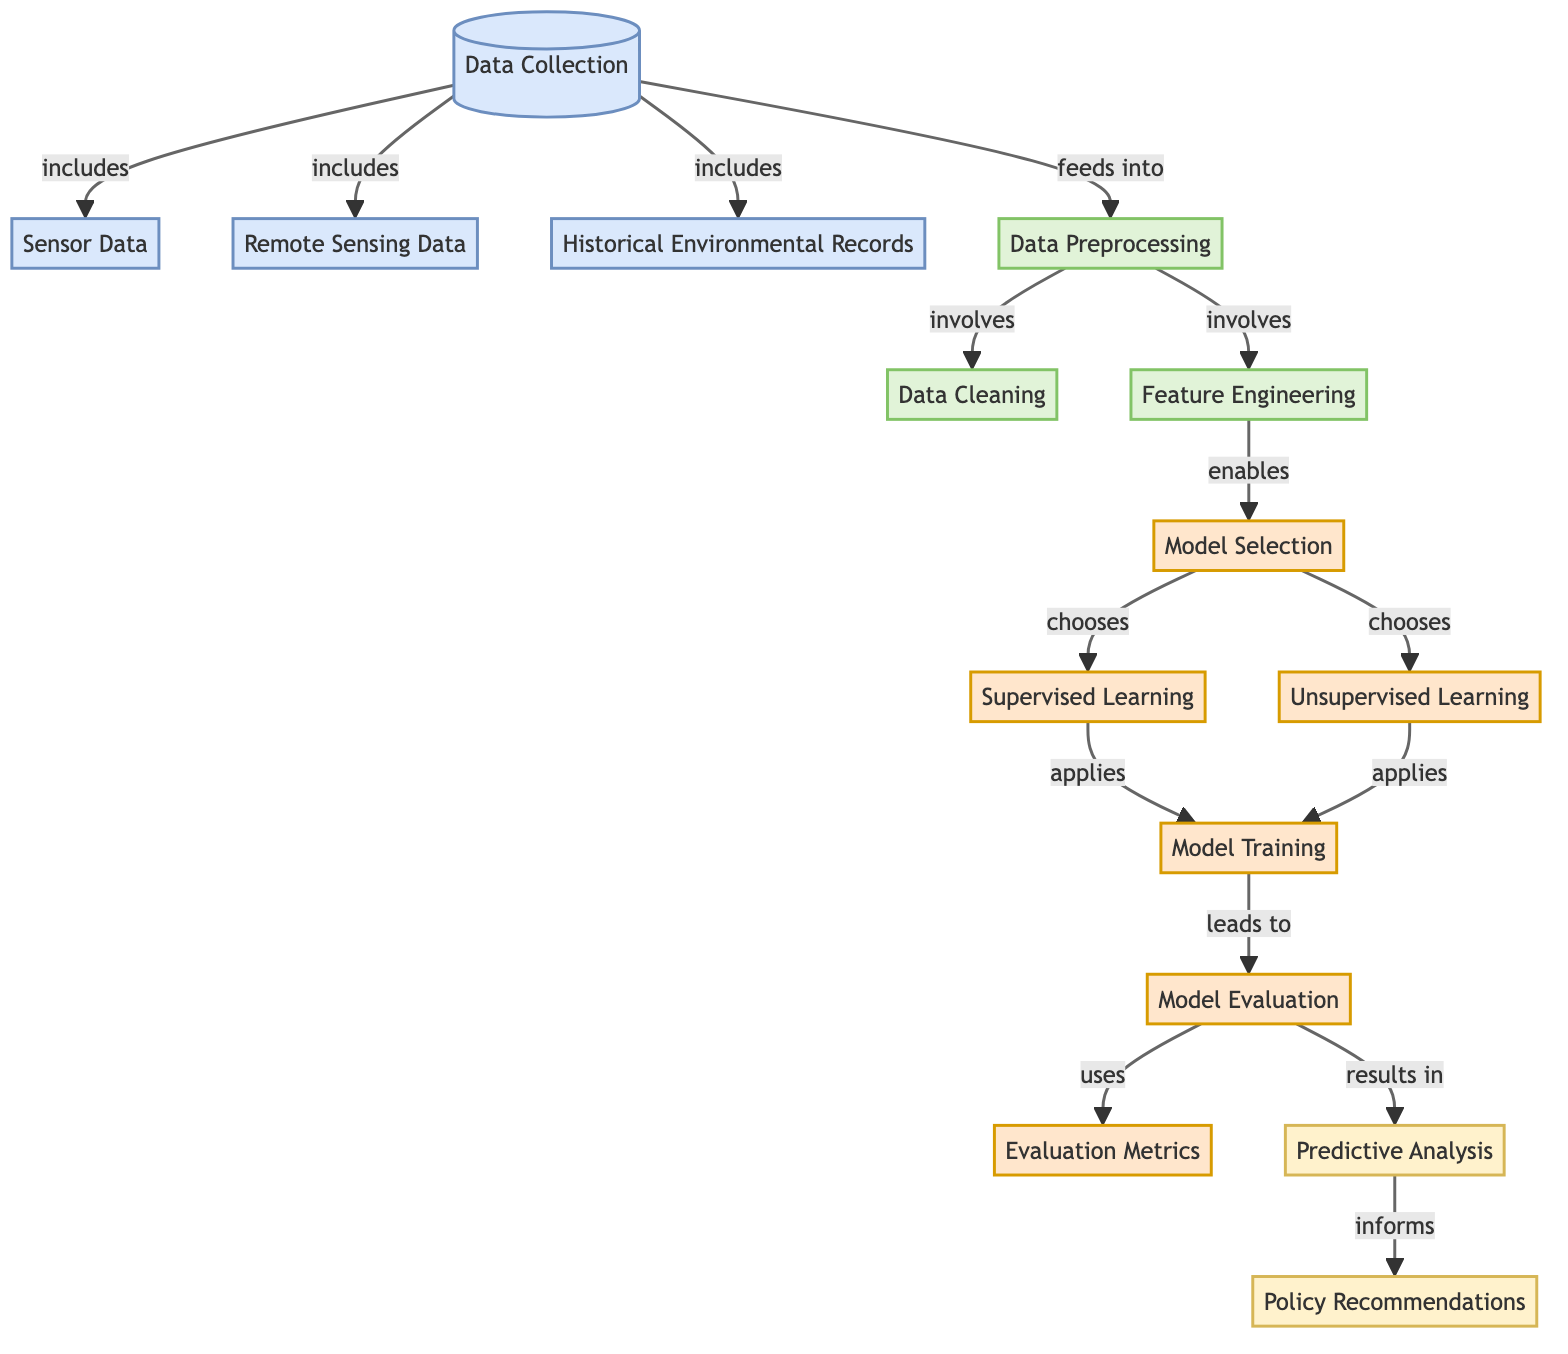What is the first step in the diagram? The first step is "Data Collection," which is indicated at the top of the diagram as the initial process before any preprocessing occurs.
Answer: Data Collection How many types of data are listed under data collection? There are three types of data listed: Sensor Data, Remote Sensing Data, and Historical Environmental Records. This can be counted by referencing the connections made under the Data Collection node.
Answer: Three Which process comes after data cleaning? After data cleaning, the next process is "Feature Engineering." The flow of the diagram shows that "Data Preprocessing" further involves both "Data Cleaning" and "Feature Engineering."
Answer: Feature Engineering What are the output nodes in this diagram? The output nodes are "Predictive Analysis" and "Policy Recommendations," both of which receive information from the "Model Evaluation" step, as shown towards the bottom of the diagram.
Answer: Predictive Analysis, Policy Recommendations Which learning method applies to both supervised and unsupervised learning? The learning method that applies to both is "Model Training," as both supervised and unsupervised learning processes lead into it according to the connections made in the diagram.
Answer: Model Training What does model evaluation use to assess its effectiveness? "Model Evaluation" uses "Evaluation Metrics" to assess effectiveness, as indicated by the direct connection leading from the evaluation metrics node to the model evaluation node.
Answer: Evaluation Metrics What does predictive analysis inform? "Predictive Analysis" informs "Policy Recommendations," which is shown by the directed flow from predictive analysis to policy recommendations in the diagram.
Answer: Policy Recommendations Which stage is characterized by choosing between supervised and unsupervised learning? The stage characterized by this decision is "Model Selection," as it displays the option to choose either supervised or unsupervised learning methods.
Answer: Model Selection What precedes the model training process? The process that precedes "Model Training" is "Model Selection." This can be observed from the arrows directing towards model training from the model selection node.
Answer: Model Selection 